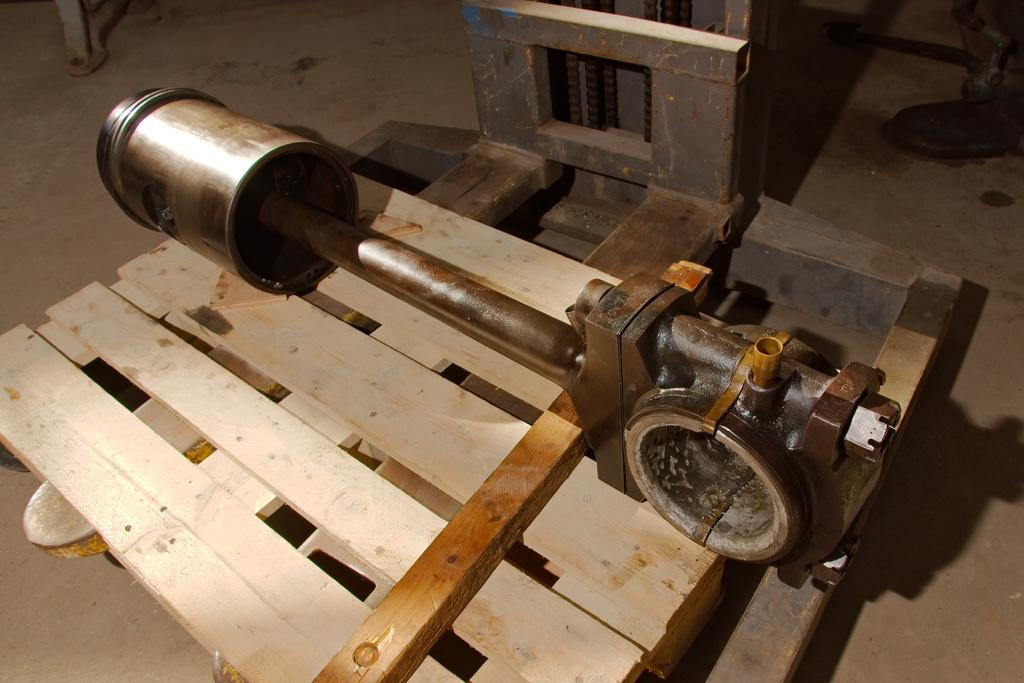What is the main subject in the middle of the image? There is a machine in the middle of the image. What can be seen on the top right side of the image? There is an object on the top right side of the image. What can be seen on the top left side of the image? There is an object on the top left side of the image. How many chickens are visible in the image? There are no chickens present in the image. What type of mask is being worn by the person in the image? There is no person or mask present in the image. 